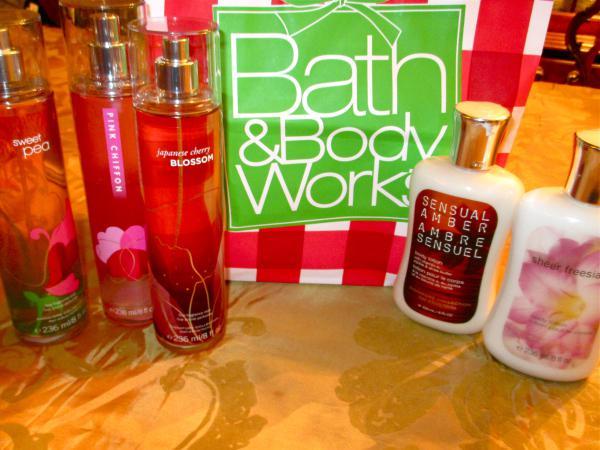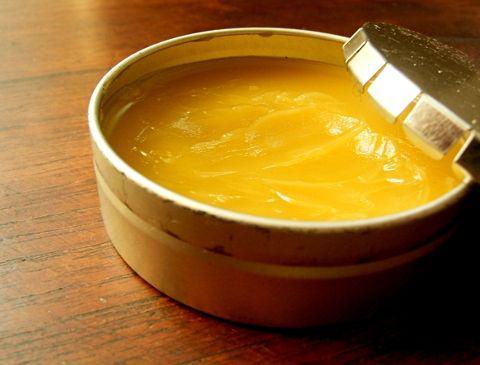The first image is the image on the left, the second image is the image on the right. Assess this claim about the two images: "A pump bottle of lotion is in one image with two other labeled products, while the second image shows an open jar of body cream among other items.". Correct or not? Answer yes or no. No. 